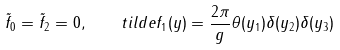<formula> <loc_0><loc_0><loc_500><loc_500>\tilde { f } _ { 0 } = \tilde { f } _ { 2 } = 0 , \quad t i l d e { f } _ { 1 } ( y ) = { \frac { 2 \pi } { g } } \theta ( y _ { 1 } ) \delta ( y _ { 2 } ) \delta ( y _ { 3 } )</formula> 